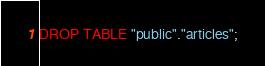<code> <loc_0><loc_0><loc_500><loc_500><_SQL_>DROP TABLE "public"."articles";
</code> 